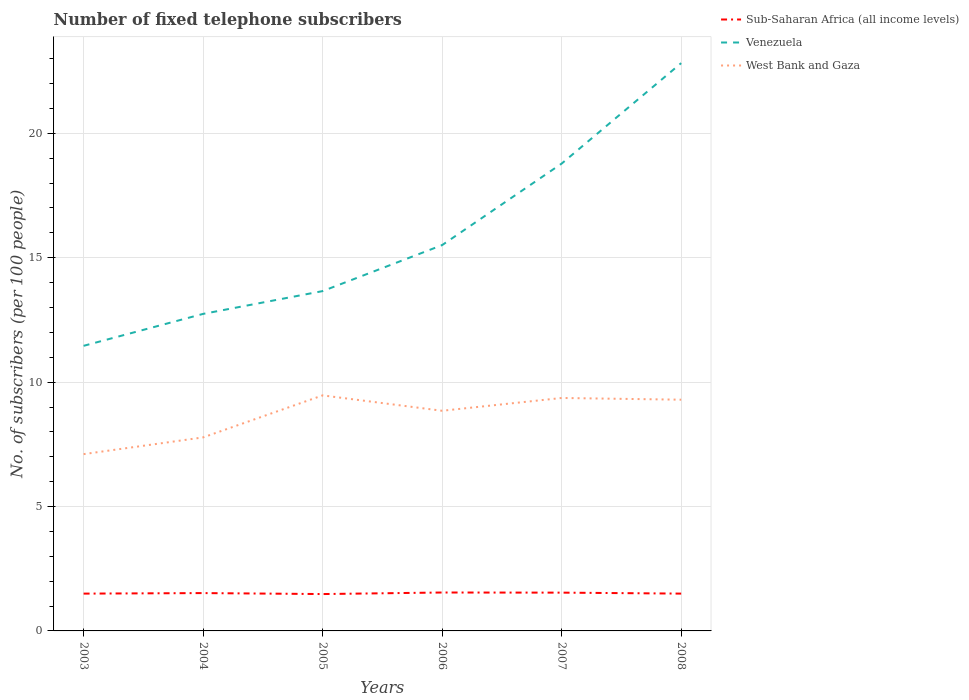Across all years, what is the maximum number of fixed telephone subscribers in Venezuela?
Provide a succinct answer. 11.46. In which year was the number of fixed telephone subscribers in Sub-Saharan Africa (all income levels) maximum?
Make the answer very short. 2005. What is the total number of fixed telephone subscribers in Venezuela in the graph?
Keep it short and to the point. -7.33. What is the difference between the highest and the second highest number of fixed telephone subscribers in Sub-Saharan Africa (all income levels)?
Offer a terse response. 0.06. What is the difference between the highest and the lowest number of fixed telephone subscribers in Sub-Saharan Africa (all income levels)?
Keep it short and to the point. 3. Is the number of fixed telephone subscribers in West Bank and Gaza strictly greater than the number of fixed telephone subscribers in Venezuela over the years?
Ensure brevity in your answer.  Yes. What is the difference between two consecutive major ticks on the Y-axis?
Offer a very short reply. 5. Are the values on the major ticks of Y-axis written in scientific E-notation?
Give a very brief answer. No. Does the graph contain grids?
Provide a short and direct response. Yes. How many legend labels are there?
Ensure brevity in your answer.  3. How are the legend labels stacked?
Your answer should be compact. Vertical. What is the title of the graph?
Provide a succinct answer. Number of fixed telephone subscribers. Does "Latvia" appear as one of the legend labels in the graph?
Provide a succinct answer. No. What is the label or title of the X-axis?
Make the answer very short. Years. What is the label or title of the Y-axis?
Your response must be concise. No. of subscribers (per 100 people). What is the No. of subscribers (per 100 people) in Sub-Saharan Africa (all income levels) in 2003?
Keep it short and to the point. 1.5. What is the No. of subscribers (per 100 people) of Venezuela in 2003?
Keep it short and to the point. 11.46. What is the No. of subscribers (per 100 people) in West Bank and Gaza in 2003?
Your response must be concise. 7.11. What is the No. of subscribers (per 100 people) in Sub-Saharan Africa (all income levels) in 2004?
Keep it short and to the point. 1.52. What is the No. of subscribers (per 100 people) in Venezuela in 2004?
Provide a succinct answer. 12.74. What is the No. of subscribers (per 100 people) in West Bank and Gaza in 2004?
Make the answer very short. 7.78. What is the No. of subscribers (per 100 people) of Sub-Saharan Africa (all income levels) in 2005?
Provide a short and direct response. 1.48. What is the No. of subscribers (per 100 people) of Venezuela in 2005?
Offer a terse response. 13.66. What is the No. of subscribers (per 100 people) in West Bank and Gaza in 2005?
Provide a short and direct response. 9.47. What is the No. of subscribers (per 100 people) in Sub-Saharan Africa (all income levels) in 2006?
Provide a succinct answer. 1.54. What is the No. of subscribers (per 100 people) of Venezuela in 2006?
Keep it short and to the point. 15.51. What is the No. of subscribers (per 100 people) in West Bank and Gaza in 2006?
Your answer should be compact. 8.85. What is the No. of subscribers (per 100 people) of Sub-Saharan Africa (all income levels) in 2007?
Ensure brevity in your answer.  1.54. What is the No. of subscribers (per 100 people) in Venezuela in 2007?
Provide a succinct answer. 18.78. What is the No. of subscribers (per 100 people) in West Bank and Gaza in 2007?
Your answer should be very brief. 9.36. What is the No. of subscribers (per 100 people) in Sub-Saharan Africa (all income levels) in 2008?
Give a very brief answer. 1.5. What is the No. of subscribers (per 100 people) in Venezuela in 2008?
Offer a terse response. 22.82. What is the No. of subscribers (per 100 people) of West Bank and Gaza in 2008?
Your answer should be very brief. 9.29. Across all years, what is the maximum No. of subscribers (per 100 people) of Sub-Saharan Africa (all income levels)?
Offer a very short reply. 1.54. Across all years, what is the maximum No. of subscribers (per 100 people) of Venezuela?
Give a very brief answer. 22.82. Across all years, what is the maximum No. of subscribers (per 100 people) in West Bank and Gaza?
Give a very brief answer. 9.47. Across all years, what is the minimum No. of subscribers (per 100 people) of Sub-Saharan Africa (all income levels)?
Ensure brevity in your answer.  1.48. Across all years, what is the minimum No. of subscribers (per 100 people) in Venezuela?
Make the answer very short. 11.46. Across all years, what is the minimum No. of subscribers (per 100 people) of West Bank and Gaza?
Ensure brevity in your answer.  7.11. What is the total No. of subscribers (per 100 people) of Sub-Saharan Africa (all income levels) in the graph?
Make the answer very short. 9.08. What is the total No. of subscribers (per 100 people) of Venezuela in the graph?
Ensure brevity in your answer.  94.98. What is the total No. of subscribers (per 100 people) of West Bank and Gaza in the graph?
Your response must be concise. 51.86. What is the difference between the No. of subscribers (per 100 people) of Sub-Saharan Africa (all income levels) in 2003 and that in 2004?
Ensure brevity in your answer.  -0.02. What is the difference between the No. of subscribers (per 100 people) in Venezuela in 2003 and that in 2004?
Your answer should be very brief. -1.28. What is the difference between the No. of subscribers (per 100 people) in West Bank and Gaza in 2003 and that in 2004?
Ensure brevity in your answer.  -0.67. What is the difference between the No. of subscribers (per 100 people) of Sub-Saharan Africa (all income levels) in 2003 and that in 2005?
Give a very brief answer. 0.02. What is the difference between the No. of subscribers (per 100 people) of Venezuela in 2003 and that in 2005?
Your answer should be very brief. -2.2. What is the difference between the No. of subscribers (per 100 people) in West Bank and Gaza in 2003 and that in 2005?
Your answer should be compact. -2.36. What is the difference between the No. of subscribers (per 100 people) in Sub-Saharan Africa (all income levels) in 2003 and that in 2006?
Ensure brevity in your answer.  -0.04. What is the difference between the No. of subscribers (per 100 people) in Venezuela in 2003 and that in 2006?
Your answer should be compact. -4.05. What is the difference between the No. of subscribers (per 100 people) of West Bank and Gaza in 2003 and that in 2006?
Provide a short and direct response. -1.74. What is the difference between the No. of subscribers (per 100 people) in Sub-Saharan Africa (all income levels) in 2003 and that in 2007?
Provide a succinct answer. -0.04. What is the difference between the No. of subscribers (per 100 people) of Venezuela in 2003 and that in 2007?
Ensure brevity in your answer.  -7.33. What is the difference between the No. of subscribers (per 100 people) in West Bank and Gaza in 2003 and that in 2007?
Your answer should be very brief. -2.26. What is the difference between the No. of subscribers (per 100 people) of Sub-Saharan Africa (all income levels) in 2003 and that in 2008?
Ensure brevity in your answer.  -0. What is the difference between the No. of subscribers (per 100 people) in Venezuela in 2003 and that in 2008?
Your answer should be very brief. -11.36. What is the difference between the No. of subscribers (per 100 people) of West Bank and Gaza in 2003 and that in 2008?
Provide a short and direct response. -2.19. What is the difference between the No. of subscribers (per 100 people) in Sub-Saharan Africa (all income levels) in 2004 and that in 2005?
Your response must be concise. 0.04. What is the difference between the No. of subscribers (per 100 people) in Venezuela in 2004 and that in 2005?
Offer a terse response. -0.92. What is the difference between the No. of subscribers (per 100 people) in West Bank and Gaza in 2004 and that in 2005?
Your answer should be very brief. -1.69. What is the difference between the No. of subscribers (per 100 people) in Sub-Saharan Africa (all income levels) in 2004 and that in 2006?
Make the answer very short. -0.02. What is the difference between the No. of subscribers (per 100 people) in Venezuela in 2004 and that in 2006?
Your answer should be compact. -2.77. What is the difference between the No. of subscribers (per 100 people) of West Bank and Gaza in 2004 and that in 2006?
Keep it short and to the point. -1.07. What is the difference between the No. of subscribers (per 100 people) of Sub-Saharan Africa (all income levels) in 2004 and that in 2007?
Offer a terse response. -0.02. What is the difference between the No. of subscribers (per 100 people) in Venezuela in 2004 and that in 2007?
Offer a terse response. -6.04. What is the difference between the No. of subscribers (per 100 people) in West Bank and Gaza in 2004 and that in 2007?
Provide a short and direct response. -1.58. What is the difference between the No. of subscribers (per 100 people) in Sub-Saharan Africa (all income levels) in 2004 and that in 2008?
Ensure brevity in your answer.  0.02. What is the difference between the No. of subscribers (per 100 people) of Venezuela in 2004 and that in 2008?
Offer a very short reply. -10.08. What is the difference between the No. of subscribers (per 100 people) in West Bank and Gaza in 2004 and that in 2008?
Give a very brief answer. -1.52. What is the difference between the No. of subscribers (per 100 people) of Sub-Saharan Africa (all income levels) in 2005 and that in 2006?
Your answer should be very brief. -0.06. What is the difference between the No. of subscribers (per 100 people) in Venezuela in 2005 and that in 2006?
Provide a short and direct response. -1.85. What is the difference between the No. of subscribers (per 100 people) in West Bank and Gaza in 2005 and that in 2006?
Offer a very short reply. 0.62. What is the difference between the No. of subscribers (per 100 people) of Sub-Saharan Africa (all income levels) in 2005 and that in 2007?
Your response must be concise. -0.06. What is the difference between the No. of subscribers (per 100 people) in Venezuela in 2005 and that in 2007?
Provide a short and direct response. -5.13. What is the difference between the No. of subscribers (per 100 people) of West Bank and Gaza in 2005 and that in 2007?
Offer a terse response. 0.1. What is the difference between the No. of subscribers (per 100 people) in Sub-Saharan Africa (all income levels) in 2005 and that in 2008?
Give a very brief answer. -0.02. What is the difference between the No. of subscribers (per 100 people) of Venezuela in 2005 and that in 2008?
Provide a succinct answer. -9.16. What is the difference between the No. of subscribers (per 100 people) in West Bank and Gaza in 2005 and that in 2008?
Make the answer very short. 0.17. What is the difference between the No. of subscribers (per 100 people) of Sub-Saharan Africa (all income levels) in 2006 and that in 2007?
Your answer should be very brief. 0.01. What is the difference between the No. of subscribers (per 100 people) of Venezuela in 2006 and that in 2007?
Give a very brief answer. -3.28. What is the difference between the No. of subscribers (per 100 people) in West Bank and Gaza in 2006 and that in 2007?
Your answer should be compact. -0.51. What is the difference between the No. of subscribers (per 100 people) in Sub-Saharan Africa (all income levels) in 2006 and that in 2008?
Offer a very short reply. 0.04. What is the difference between the No. of subscribers (per 100 people) in Venezuela in 2006 and that in 2008?
Keep it short and to the point. -7.31. What is the difference between the No. of subscribers (per 100 people) of West Bank and Gaza in 2006 and that in 2008?
Offer a terse response. -0.45. What is the difference between the No. of subscribers (per 100 people) of Sub-Saharan Africa (all income levels) in 2007 and that in 2008?
Ensure brevity in your answer.  0.04. What is the difference between the No. of subscribers (per 100 people) in Venezuela in 2007 and that in 2008?
Provide a short and direct response. -4.04. What is the difference between the No. of subscribers (per 100 people) in West Bank and Gaza in 2007 and that in 2008?
Provide a succinct answer. 0.07. What is the difference between the No. of subscribers (per 100 people) of Sub-Saharan Africa (all income levels) in 2003 and the No. of subscribers (per 100 people) of Venezuela in 2004?
Your answer should be compact. -11.24. What is the difference between the No. of subscribers (per 100 people) of Sub-Saharan Africa (all income levels) in 2003 and the No. of subscribers (per 100 people) of West Bank and Gaza in 2004?
Ensure brevity in your answer.  -6.28. What is the difference between the No. of subscribers (per 100 people) in Venezuela in 2003 and the No. of subscribers (per 100 people) in West Bank and Gaza in 2004?
Ensure brevity in your answer.  3.68. What is the difference between the No. of subscribers (per 100 people) of Sub-Saharan Africa (all income levels) in 2003 and the No. of subscribers (per 100 people) of Venezuela in 2005?
Make the answer very short. -12.16. What is the difference between the No. of subscribers (per 100 people) in Sub-Saharan Africa (all income levels) in 2003 and the No. of subscribers (per 100 people) in West Bank and Gaza in 2005?
Your response must be concise. -7.97. What is the difference between the No. of subscribers (per 100 people) of Venezuela in 2003 and the No. of subscribers (per 100 people) of West Bank and Gaza in 2005?
Ensure brevity in your answer.  1.99. What is the difference between the No. of subscribers (per 100 people) in Sub-Saharan Africa (all income levels) in 2003 and the No. of subscribers (per 100 people) in Venezuela in 2006?
Your response must be concise. -14.01. What is the difference between the No. of subscribers (per 100 people) in Sub-Saharan Africa (all income levels) in 2003 and the No. of subscribers (per 100 people) in West Bank and Gaza in 2006?
Make the answer very short. -7.35. What is the difference between the No. of subscribers (per 100 people) of Venezuela in 2003 and the No. of subscribers (per 100 people) of West Bank and Gaza in 2006?
Ensure brevity in your answer.  2.61. What is the difference between the No. of subscribers (per 100 people) in Sub-Saharan Africa (all income levels) in 2003 and the No. of subscribers (per 100 people) in Venezuela in 2007?
Your answer should be compact. -17.29. What is the difference between the No. of subscribers (per 100 people) in Sub-Saharan Africa (all income levels) in 2003 and the No. of subscribers (per 100 people) in West Bank and Gaza in 2007?
Provide a succinct answer. -7.86. What is the difference between the No. of subscribers (per 100 people) of Venezuela in 2003 and the No. of subscribers (per 100 people) of West Bank and Gaza in 2007?
Give a very brief answer. 2.1. What is the difference between the No. of subscribers (per 100 people) of Sub-Saharan Africa (all income levels) in 2003 and the No. of subscribers (per 100 people) of Venezuela in 2008?
Make the answer very short. -21.32. What is the difference between the No. of subscribers (per 100 people) in Sub-Saharan Africa (all income levels) in 2003 and the No. of subscribers (per 100 people) in West Bank and Gaza in 2008?
Your answer should be very brief. -7.79. What is the difference between the No. of subscribers (per 100 people) in Venezuela in 2003 and the No. of subscribers (per 100 people) in West Bank and Gaza in 2008?
Offer a terse response. 2.17. What is the difference between the No. of subscribers (per 100 people) of Sub-Saharan Africa (all income levels) in 2004 and the No. of subscribers (per 100 people) of Venezuela in 2005?
Make the answer very short. -12.14. What is the difference between the No. of subscribers (per 100 people) in Sub-Saharan Africa (all income levels) in 2004 and the No. of subscribers (per 100 people) in West Bank and Gaza in 2005?
Provide a succinct answer. -7.95. What is the difference between the No. of subscribers (per 100 people) in Venezuela in 2004 and the No. of subscribers (per 100 people) in West Bank and Gaza in 2005?
Give a very brief answer. 3.28. What is the difference between the No. of subscribers (per 100 people) of Sub-Saharan Africa (all income levels) in 2004 and the No. of subscribers (per 100 people) of Venezuela in 2006?
Keep it short and to the point. -13.99. What is the difference between the No. of subscribers (per 100 people) in Sub-Saharan Africa (all income levels) in 2004 and the No. of subscribers (per 100 people) in West Bank and Gaza in 2006?
Give a very brief answer. -7.33. What is the difference between the No. of subscribers (per 100 people) in Venezuela in 2004 and the No. of subscribers (per 100 people) in West Bank and Gaza in 2006?
Provide a short and direct response. 3.89. What is the difference between the No. of subscribers (per 100 people) in Sub-Saharan Africa (all income levels) in 2004 and the No. of subscribers (per 100 people) in Venezuela in 2007?
Your answer should be compact. -17.26. What is the difference between the No. of subscribers (per 100 people) in Sub-Saharan Africa (all income levels) in 2004 and the No. of subscribers (per 100 people) in West Bank and Gaza in 2007?
Offer a terse response. -7.84. What is the difference between the No. of subscribers (per 100 people) in Venezuela in 2004 and the No. of subscribers (per 100 people) in West Bank and Gaza in 2007?
Ensure brevity in your answer.  3.38. What is the difference between the No. of subscribers (per 100 people) of Sub-Saharan Africa (all income levels) in 2004 and the No. of subscribers (per 100 people) of Venezuela in 2008?
Your answer should be compact. -21.3. What is the difference between the No. of subscribers (per 100 people) of Sub-Saharan Africa (all income levels) in 2004 and the No. of subscribers (per 100 people) of West Bank and Gaza in 2008?
Your answer should be very brief. -7.77. What is the difference between the No. of subscribers (per 100 people) in Venezuela in 2004 and the No. of subscribers (per 100 people) in West Bank and Gaza in 2008?
Give a very brief answer. 3.45. What is the difference between the No. of subscribers (per 100 people) in Sub-Saharan Africa (all income levels) in 2005 and the No. of subscribers (per 100 people) in Venezuela in 2006?
Your response must be concise. -14.03. What is the difference between the No. of subscribers (per 100 people) of Sub-Saharan Africa (all income levels) in 2005 and the No. of subscribers (per 100 people) of West Bank and Gaza in 2006?
Your answer should be compact. -7.37. What is the difference between the No. of subscribers (per 100 people) of Venezuela in 2005 and the No. of subscribers (per 100 people) of West Bank and Gaza in 2006?
Your response must be concise. 4.81. What is the difference between the No. of subscribers (per 100 people) of Sub-Saharan Africa (all income levels) in 2005 and the No. of subscribers (per 100 people) of Venezuela in 2007?
Give a very brief answer. -17.3. What is the difference between the No. of subscribers (per 100 people) in Sub-Saharan Africa (all income levels) in 2005 and the No. of subscribers (per 100 people) in West Bank and Gaza in 2007?
Make the answer very short. -7.88. What is the difference between the No. of subscribers (per 100 people) in Venezuela in 2005 and the No. of subscribers (per 100 people) in West Bank and Gaza in 2007?
Offer a terse response. 4.3. What is the difference between the No. of subscribers (per 100 people) of Sub-Saharan Africa (all income levels) in 2005 and the No. of subscribers (per 100 people) of Venezuela in 2008?
Offer a terse response. -21.34. What is the difference between the No. of subscribers (per 100 people) of Sub-Saharan Africa (all income levels) in 2005 and the No. of subscribers (per 100 people) of West Bank and Gaza in 2008?
Ensure brevity in your answer.  -7.81. What is the difference between the No. of subscribers (per 100 people) in Venezuela in 2005 and the No. of subscribers (per 100 people) in West Bank and Gaza in 2008?
Your answer should be compact. 4.37. What is the difference between the No. of subscribers (per 100 people) of Sub-Saharan Africa (all income levels) in 2006 and the No. of subscribers (per 100 people) of Venezuela in 2007?
Your response must be concise. -17.24. What is the difference between the No. of subscribers (per 100 people) of Sub-Saharan Africa (all income levels) in 2006 and the No. of subscribers (per 100 people) of West Bank and Gaza in 2007?
Offer a very short reply. -7.82. What is the difference between the No. of subscribers (per 100 people) in Venezuela in 2006 and the No. of subscribers (per 100 people) in West Bank and Gaza in 2007?
Provide a short and direct response. 6.14. What is the difference between the No. of subscribers (per 100 people) in Sub-Saharan Africa (all income levels) in 2006 and the No. of subscribers (per 100 people) in Venezuela in 2008?
Your answer should be very brief. -21.28. What is the difference between the No. of subscribers (per 100 people) in Sub-Saharan Africa (all income levels) in 2006 and the No. of subscribers (per 100 people) in West Bank and Gaza in 2008?
Provide a succinct answer. -7.75. What is the difference between the No. of subscribers (per 100 people) in Venezuela in 2006 and the No. of subscribers (per 100 people) in West Bank and Gaza in 2008?
Your answer should be compact. 6.21. What is the difference between the No. of subscribers (per 100 people) of Sub-Saharan Africa (all income levels) in 2007 and the No. of subscribers (per 100 people) of Venezuela in 2008?
Your response must be concise. -21.28. What is the difference between the No. of subscribers (per 100 people) in Sub-Saharan Africa (all income levels) in 2007 and the No. of subscribers (per 100 people) in West Bank and Gaza in 2008?
Offer a very short reply. -7.76. What is the difference between the No. of subscribers (per 100 people) of Venezuela in 2007 and the No. of subscribers (per 100 people) of West Bank and Gaza in 2008?
Keep it short and to the point. 9.49. What is the average No. of subscribers (per 100 people) in Sub-Saharan Africa (all income levels) per year?
Make the answer very short. 1.51. What is the average No. of subscribers (per 100 people) of Venezuela per year?
Provide a short and direct response. 15.83. What is the average No. of subscribers (per 100 people) of West Bank and Gaza per year?
Ensure brevity in your answer.  8.64. In the year 2003, what is the difference between the No. of subscribers (per 100 people) in Sub-Saharan Africa (all income levels) and No. of subscribers (per 100 people) in Venezuela?
Keep it short and to the point. -9.96. In the year 2003, what is the difference between the No. of subscribers (per 100 people) in Sub-Saharan Africa (all income levels) and No. of subscribers (per 100 people) in West Bank and Gaza?
Ensure brevity in your answer.  -5.61. In the year 2003, what is the difference between the No. of subscribers (per 100 people) of Venezuela and No. of subscribers (per 100 people) of West Bank and Gaza?
Ensure brevity in your answer.  4.35. In the year 2004, what is the difference between the No. of subscribers (per 100 people) in Sub-Saharan Africa (all income levels) and No. of subscribers (per 100 people) in Venezuela?
Your answer should be very brief. -11.22. In the year 2004, what is the difference between the No. of subscribers (per 100 people) of Sub-Saharan Africa (all income levels) and No. of subscribers (per 100 people) of West Bank and Gaza?
Your response must be concise. -6.26. In the year 2004, what is the difference between the No. of subscribers (per 100 people) in Venezuela and No. of subscribers (per 100 people) in West Bank and Gaza?
Ensure brevity in your answer.  4.96. In the year 2005, what is the difference between the No. of subscribers (per 100 people) of Sub-Saharan Africa (all income levels) and No. of subscribers (per 100 people) of Venezuela?
Give a very brief answer. -12.18. In the year 2005, what is the difference between the No. of subscribers (per 100 people) in Sub-Saharan Africa (all income levels) and No. of subscribers (per 100 people) in West Bank and Gaza?
Make the answer very short. -7.99. In the year 2005, what is the difference between the No. of subscribers (per 100 people) in Venezuela and No. of subscribers (per 100 people) in West Bank and Gaza?
Keep it short and to the point. 4.19. In the year 2006, what is the difference between the No. of subscribers (per 100 people) in Sub-Saharan Africa (all income levels) and No. of subscribers (per 100 people) in Venezuela?
Your answer should be very brief. -13.96. In the year 2006, what is the difference between the No. of subscribers (per 100 people) of Sub-Saharan Africa (all income levels) and No. of subscribers (per 100 people) of West Bank and Gaza?
Ensure brevity in your answer.  -7.3. In the year 2006, what is the difference between the No. of subscribers (per 100 people) in Venezuela and No. of subscribers (per 100 people) in West Bank and Gaza?
Offer a very short reply. 6.66. In the year 2007, what is the difference between the No. of subscribers (per 100 people) in Sub-Saharan Africa (all income levels) and No. of subscribers (per 100 people) in Venezuela?
Keep it short and to the point. -17.25. In the year 2007, what is the difference between the No. of subscribers (per 100 people) of Sub-Saharan Africa (all income levels) and No. of subscribers (per 100 people) of West Bank and Gaza?
Make the answer very short. -7.82. In the year 2007, what is the difference between the No. of subscribers (per 100 people) of Venezuela and No. of subscribers (per 100 people) of West Bank and Gaza?
Give a very brief answer. 9.42. In the year 2008, what is the difference between the No. of subscribers (per 100 people) in Sub-Saharan Africa (all income levels) and No. of subscribers (per 100 people) in Venezuela?
Ensure brevity in your answer.  -21.32. In the year 2008, what is the difference between the No. of subscribers (per 100 people) of Sub-Saharan Africa (all income levels) and No. of subscribers (per 100 people) of West Bank and Gaza?
Make the answer very short. -7.79. In the year 2008, what is the difference between the No. of subscribers (per 100 people) in Venezuela and No. of subscribers (per 100 people) in West Bank and Gaza?
Your response must be concise. 13.53. What is the ratio of the No. of subscribers (per 100 people) of Sub-Saharan Africa (all income levels) in 2003 to that in 2004?
Offer a terse response. 0.99. What is the ratio of the No. of subscribers (per 100 people) of Venezuela in 2003 to that in 2004?
Provide a succinct answer. 0.9. What is the ratio of the No. of subscribers (per 100 people) of West Bank and Gaza in 2003 to that in 2004?
Offer a very short reply. 0.91. What is the ratio of the No. of subscribers (per 100 people) of Sub-Saharan Africa (all income levels) in 2003 to that in 2005?
Your response must be concise. 1.01. What is the ratio of the No. of subscribers (per 100 people) in Venezuela in 2003 to that in 2005?
Give a very brief answer. 0.84. What is the ratio of the No. of subscribers (per 100 people) of West Bank and Gaza in 2003 to that in 2005?
Ensure brevity in your answer.  0.75. What is the ratio of the No. of subscribers (per 100 people) in Sub-Saharan Africa (all income levels) in 2003 to that in 2006?
Keep it short and to the point. 0.97. What is the ratio of the No. of subscribers (per 100 people) in Venezuela in 2003 to that in 2006?
Give a very brief answer. 0.74. What is the ratio of the No. of subscribers (per 100 people) in West Bank and Gaza in 2003 to that in 2006?
Your answer should be very brief. 0.8. What is the ratio of the No. of subscribers (per 100 people) of Sub-Saharan Africa (all income levels) in 2003 to that in 2007?
Make the answer very short. 0.97. What is the ratio of the No. of subscribers (per 100 people) in Venezuela in 2003 to that in 2007?
Provide a short and direct response. 0.61. What is the ratio of the No. of subscribers (per 100 people) in West Bank and Gaza in 2003 to that in 2007?
Offer a very short reply. 0.76. What is the ratio of the No. of subscribers (per 100 people) of Venezuela in 2003 to that in 2008?
Your response must be concise. 0.5. What is the ratio of the No. of subscribers (per 100 people) of West Bank and Gaza in 2003 to that in 2008?
Offer a very short reply. 0.76. What is the ratio of the No. of subscribers (per 100 people) in Sub-Saharan Africa (all income levels) in 2004 to that in 2005?
Your answer should be compact. 1.03. What is the ratio of the No. of subscribers (per 100 people) in Venezuela in 2004 to that in 2005?
Ensure brevity in your answer.  0.93. What is the ratio of the No. of subscribers (per 100 people) in West Bank and Gaza in 2004 to that in 2005?
Provide a succinct answer. 0.82. What is the ratio of the No. of subscribers (per 100 people) in Venezuela in 2004 to that in 2006?
Give a very brief answer. 0.82. What is the ratio of the No. of subscribers (per 100 people) of West Bank and Gaza in 2004 to that in 2006?
Your answer should be compact. 0.88. What is the ratio of the No. of subscribers (per 100 people) of Sub-Saharan Africa (all income levels) in 2004 to that in 2007?
Provide a succinct answer. 0.99. What is the ratio of the No. of subscribers (per 100 people) of Venezuela in 2004 to that in 2007?
Give a very brief answer. 0.68. What is the ratio of the No. of subscribers (per 100 people) of West Bank and Gaza in 2004 to that in 2007?
Offer a very short reply. 0.83. What is the ratio of the No. of subscribers (per 100 people) in Sub-Saharan Africa (all income levels) in 2004 to that in 2008?
Offer a very short reply. 1.01. What is the ratio of the No. of subscribers (per 100 people) in Venezuela in 2004 to that in 2008?
Offer a very short reply. 0.56. What is the ratio of the No. of subscribers (per 100 people) of West Bank and Gaza in 2004 to that in 2008?
Your answer should be compact. 0.84. What is the ratio of the No. of subscribers (per 100 people) in Sub-Saharan Africa (all income levels) in 2005 to that in 2006?
Make the answer very short. 0.96. What is the ratio of the No. of subscribers (per 100 people) of Venezuela in 2005 to that in 2006?
Offer a very short reply. 0.88. What is the ratio of the No. of subscribers (per 100 people) in West Bank and Gaza in 2005 to that in 2006?
Your answer should be compact. 1.07. What is the ratio of the No. of subscribers (per 100 people) of Sub-Saharan Africa (all income levels) in 2005 to that in 2007?
Your answer should be very brief. 0.96. What is the ratio of the No. of subscribers (per 100 people) in Venezuela in 2005 to that in 2007?
Offer a very short reply. 0.73. What is the ratio of the No. of subscribers (per 100 people) of West Bank and Gaza in 2005 to that in 2007?
Your answer should be compact. 1.01. What is the ratio of the No. of subscribers (per 100 people) of Venezuela in 2005 to that in 2008?
Your answer should be very brief. 0.6. What is the ratio of the No. of subscribers (per 100 people) in West Bank and Gaza in 2005 to that in 2008?
Keep it short and to the point. 1.02. What is the ratio of the No. of subscribers (per 100 people) of Venezuela in 2006 to that in 2007?
Ensure brevity in your answer.  0.83. What is the ratio of the No. of subscribers (per 100 people) in West Bank and Gaza in 2006 to that in 2007?
Provide a short and direct response. 0.95. What is the ratio of the No. of subscribers (per 100 people) in Sub-Saharan Africa (all income levels) in 2006 to that in 2008?
Your response must be concise. 1.03. What is the ratio of the No. of subscribers (per 100 people) of Venezuela in 2006 to that in 2008?
Give a very brief answer. 0.68. What is the ratio of the No. of subscribers (per 100 people) in West Bank and Gaza in 2006 to that in 2008?
Give a very brief answer. 0.95. What is the ratio of the No. of subscribers (per 100 people) of Sub-Saharan Africa (all income levels) in 2007 to that in 2008?
Provide a succinct answer. 1.03. What is the ratio of the No. of subscribers (per 100 people) in Venezuela in 2007 to that in 2008?
Provide a succinct answer. 0.82. What is the ratio of the No. of subscribers (per 100 people) of West Bank and Gaza in 2007 to that in 2008?
Keep it short and to the point. 1.01. What is the difference between the highest and the second highest No. of subscribers (per 100 people) of Sub-Saharan Africa (all income levels)?
Provide a succinct answer. 0.01. What is the difference between the highest and the second highest No. of subscribers (per 100 people) in Venezuela?
Ensure brevity in your answer.  4.04. What is the difference between the highest and the second highest No. of subscribers (per 100 people) in West Bank and Gaza?
Keep it short and to the point. 0.1. What is the difference between the highest and the lowest No. of subscribers (per 100 people) in Sub-Saharan Africa (all income levels)?
Offer a very short reply. 0.06. What is the difference between the highest and the lowest No. of subscribers (per 100 people) of Venezuela?
Your answer should be very brief. 11.36. What is the difference between the highest and the lowest No. of subscribers (per 100 people) of West Bank and Gaza?
Your answer should be very brief. 2.36. 